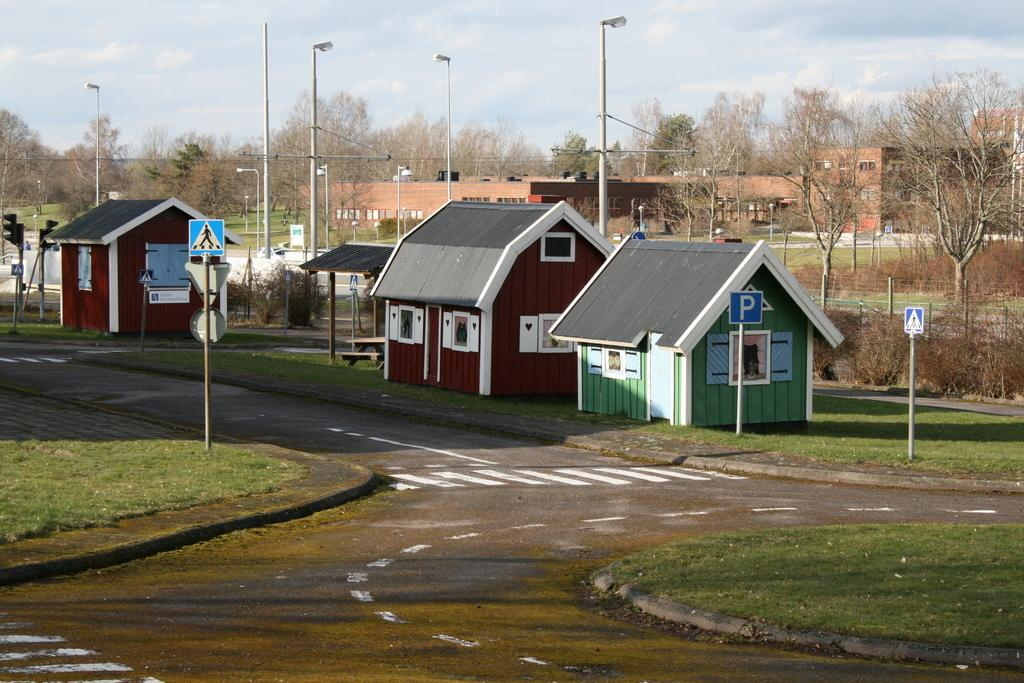What type of houses can be seen in the image? There are wooden houses in the image. What other structures are present in the image besides houses? There are buildings, poles, street lights, and signals on the road in the image. What type of vegetation is visible in the image? There are trees in the image. What is visible in the sky in the image? The sky is visible in the image. What type of patch is visible on the wooden houses in the image? There is no patch visible on the wooden houses in the image. What caption can be seen on the street lights in the image? There is no caption present on the street lights in the image. 